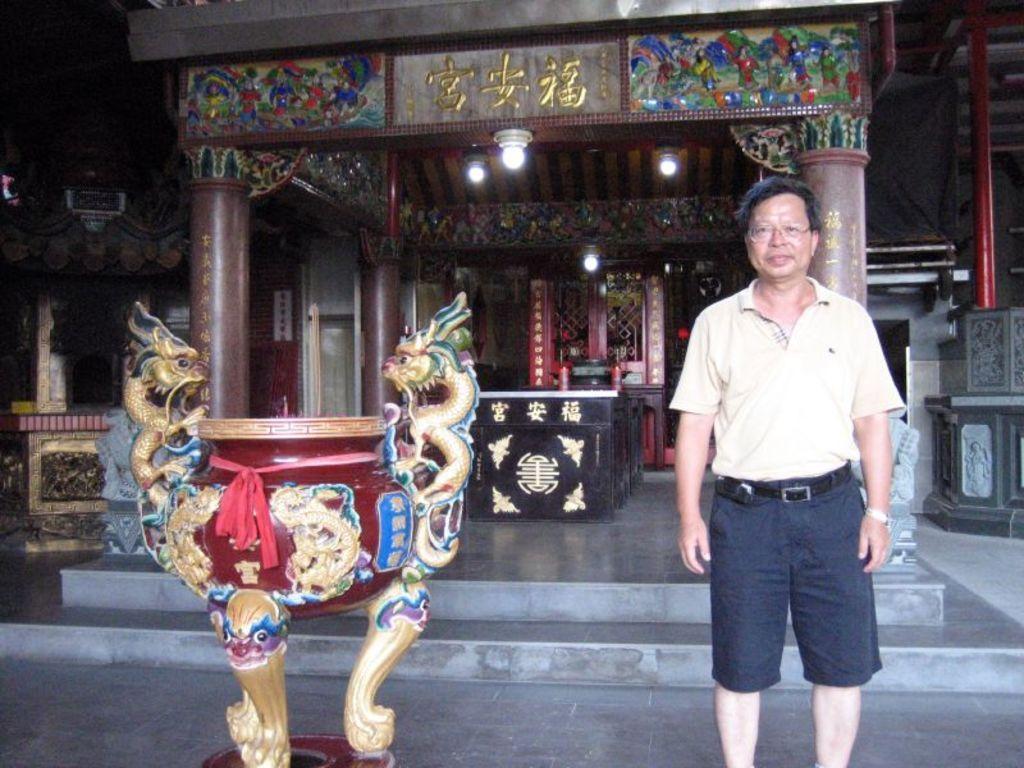In one or two sentences, can you explain what this image depicts? The man in white T-shirt who is wearing spectacles and a watch is standing. Beside him, we see a table and behind him, there is a staircase. In the middle of the picture, we see a black color table. Beside the table there are pillars. In the background, we see a door. On the right side, we see a pillar or a pole. 